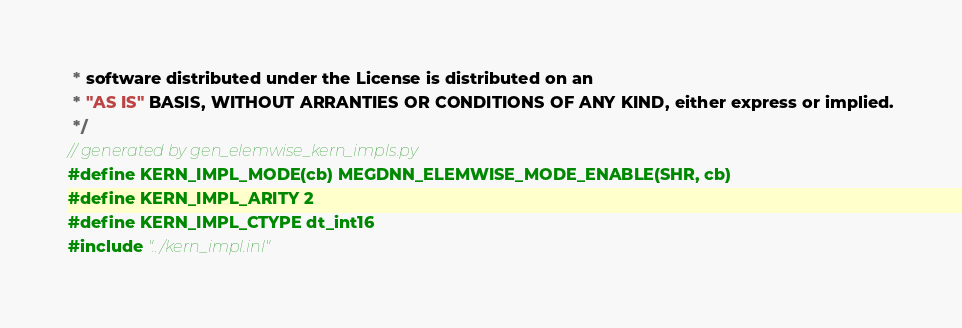<code> <loc_0><loc_0><loc_500><loc_500><_Cuda_> * software distributed under the License is distributed on an
 * "AS IS" BASIS, WITHOUT ARRANTIES OR CONDITIONS OF ANY KIND, either express or implied.
 */
// generated by gen_elemwise_kern_impls.py
#define KERN_IMPL_MODE(cb) MEGDNN_ELEMWISE_MODE_ENABLE(SHR, cb)
#define KERN_IMPL_ARITY 2
#define KERN_IMPL_CTYPE dt_int16
#include "../kern_impl.inl"
</code> 